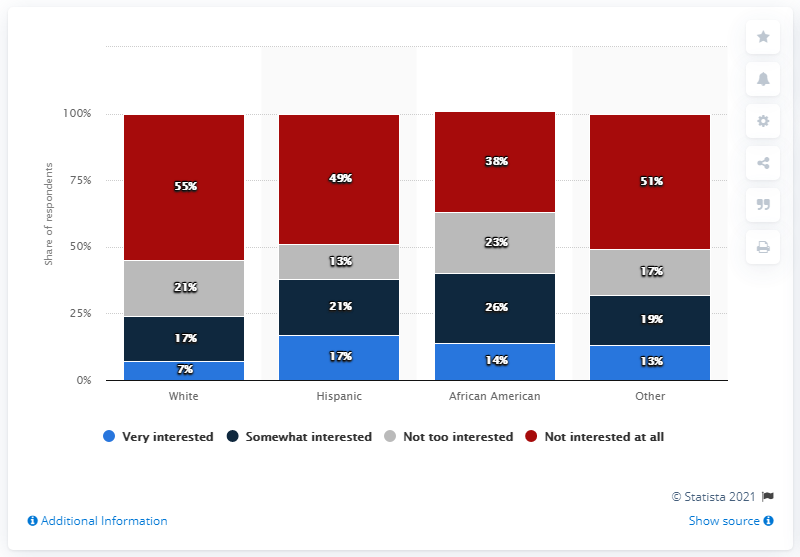What does the image suggest about the general interest in soccer across all races? The bar graph implies that soccer interests a significant portion of people across all depicted racial groups. A combined majority of respondents, regardless of race, are at least somewhat interested in soccer, with variations in the degree of interest. 